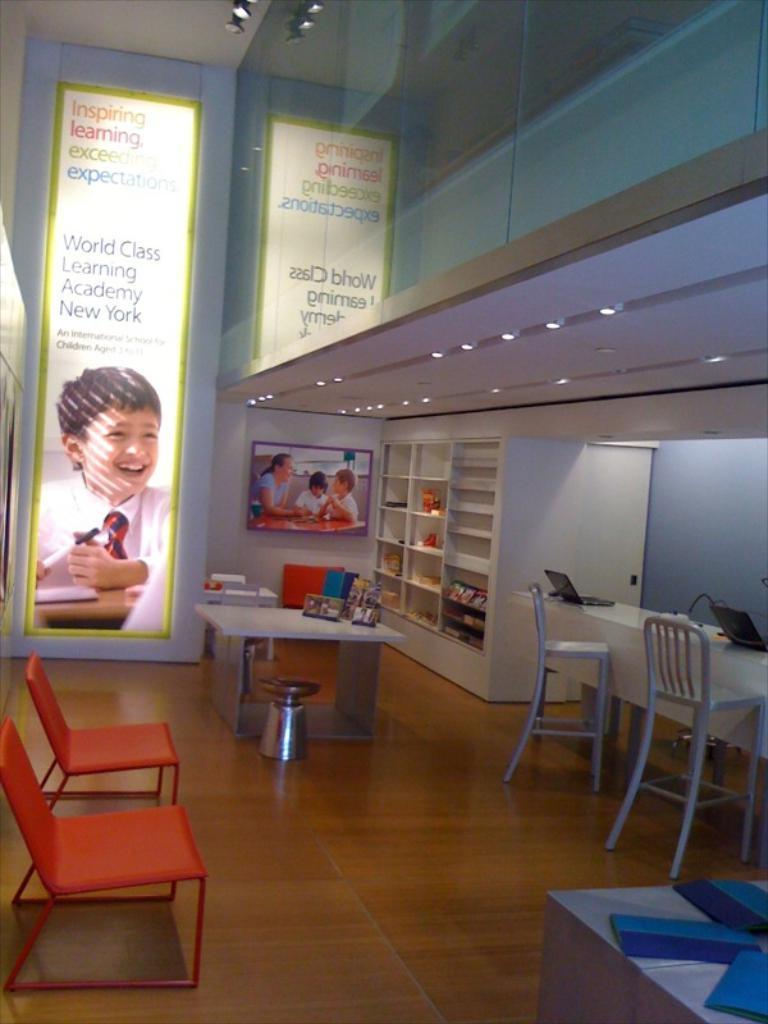Can you describe this image briefly? It seems like the picture is captured inside an organisation, there are two banners and in front of the banners there is a table on the table there are some objects. On the right side there are shelves and in the shelves of the cabinets there are some objects, on the right side there is a table and on the table there are two laptops and there are two chairs in front of the table, there are two empty chairs on the left side of the image. 